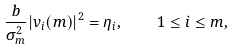<formula> <loc_0><loc_0><loc_500><loc_500>\frac { b } { \sigma _ { m } ^ { 2 } } | v _ { i } ( m ) | ^ { 2 } = \eta _ { i } , \quad 1 \leq i \leq m ,</formula> 